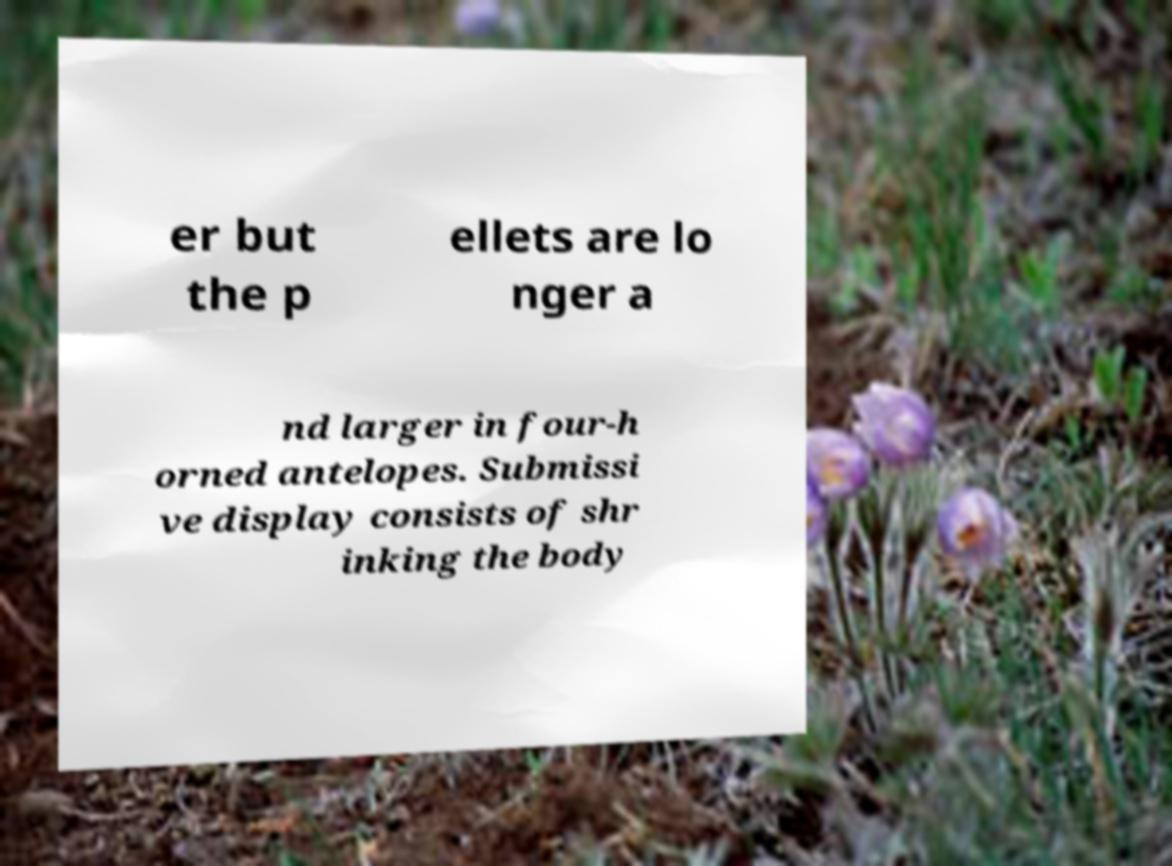I need the written content from this picture converted into text. Can you do that? er but the p ellets are lo nger a nd larger in four-h orned antelopes. Submissi ve display consists of shr inking the body 